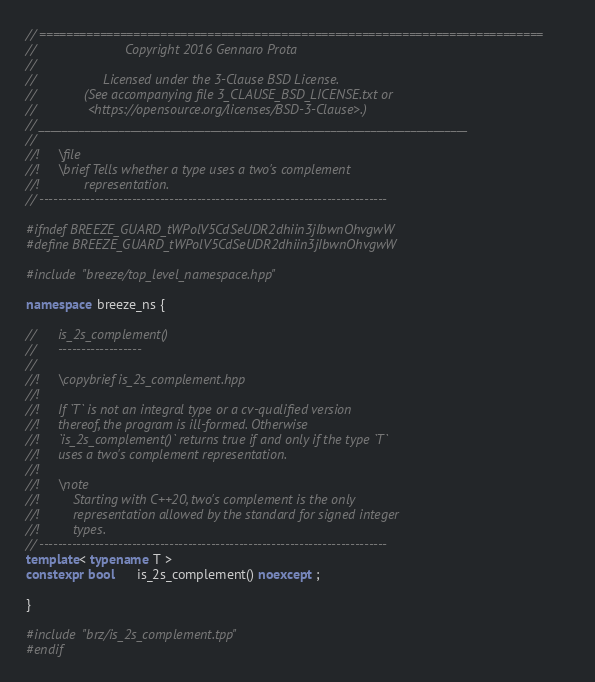<code> <loc_0><loc_0><loc_500><loc_500><_C++_>// ===========================================================================
//                        Copyright 2016 Gennaro Prota
//
//                  Licensed under the 3-Clause BSD License.
//             (See accompanying file 3_CLAUSE_BSD_LICENSE.txt or
//              <https://opensource.org/licenses/BSD-3-Clause>.)
// ___________________________________________________________________________
//
//!     \file
//!     \brief Tells whether a type uses a two's complement
//!            representation.
// ---------------------------------------------------------------------------

#ifndef BREEZE_GUARD_tWPolV5CdSeUDR2dhiin3jIbwnOhvgwW
#define BREEZE_GUARD_tWPolV5CdSeUDR2dhiin3jIbwnOhvgwW

#include "breeze/top_level_namespace.hpp"

namespace breeze_ns {

//      is_2s_complement()
//      ------------------
//
//!     \copybrief is_2s_complement.hpp
//!
//!     If `T` is not an integral type or a cv-qualified version
//!     thereof, the program is ill-formed. Otherwise
//!     `is_2s_complement()` returns true if and only if the type `T`
//!     uses a two's complement representation.
//!
//!     \note
//!         Starting with C++20, two's complement is the only
//!         representation allowed by the standard for signed integer
//!         types.
// ---------------------------------------------------------------------------
template< typename T >
constexpr bool      is_2s_complement() noexcept ;

}

#include "brz/is_2s_complement.tpp"
#endif
</code> 